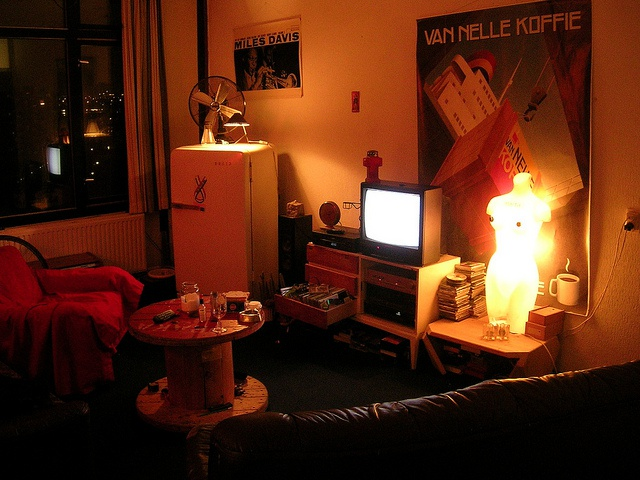Describe the objects in this image and their specific colors. I can see couch in black, maroon, and gray tones, chair in black, maroon, and brown tones, refrigerator in black, maroon, and brown tones, dining table in black, maroon, and brown tones, and tv in black, white, maroon, and brown tones in this image. 